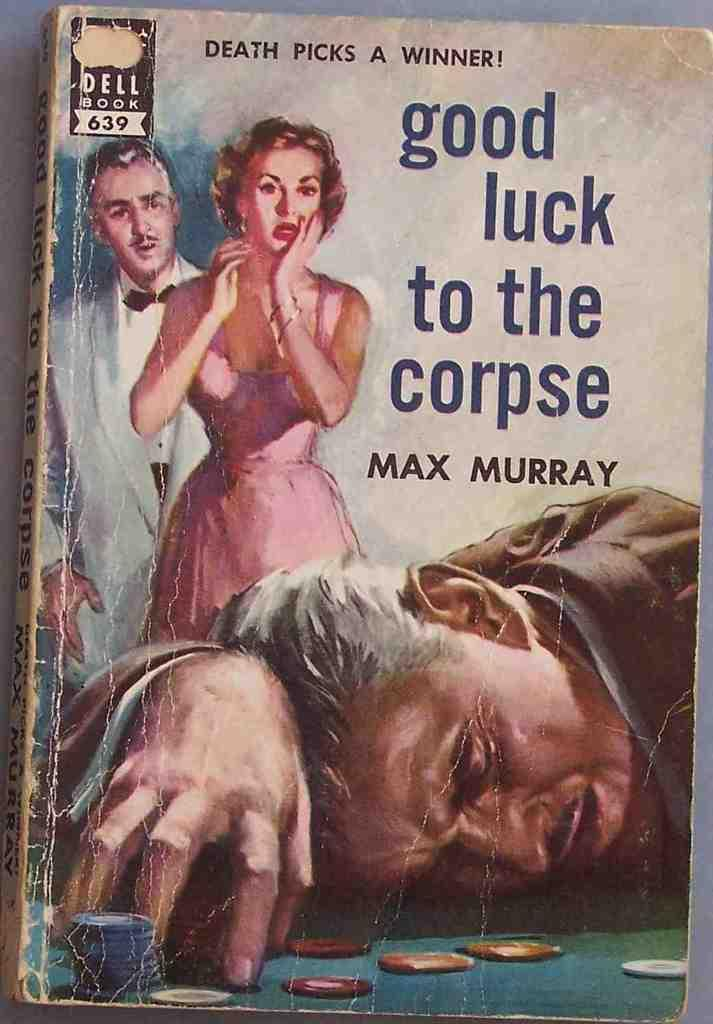<image>
Offer a succinct explanation of the picture presented. An old book with the title of Good Luck to the Corpse on it. 